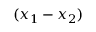<formula> <loc_0><loc_0><loc_500><loc_500>( x _ { 1 } - x _ { 2 } )</formula> 